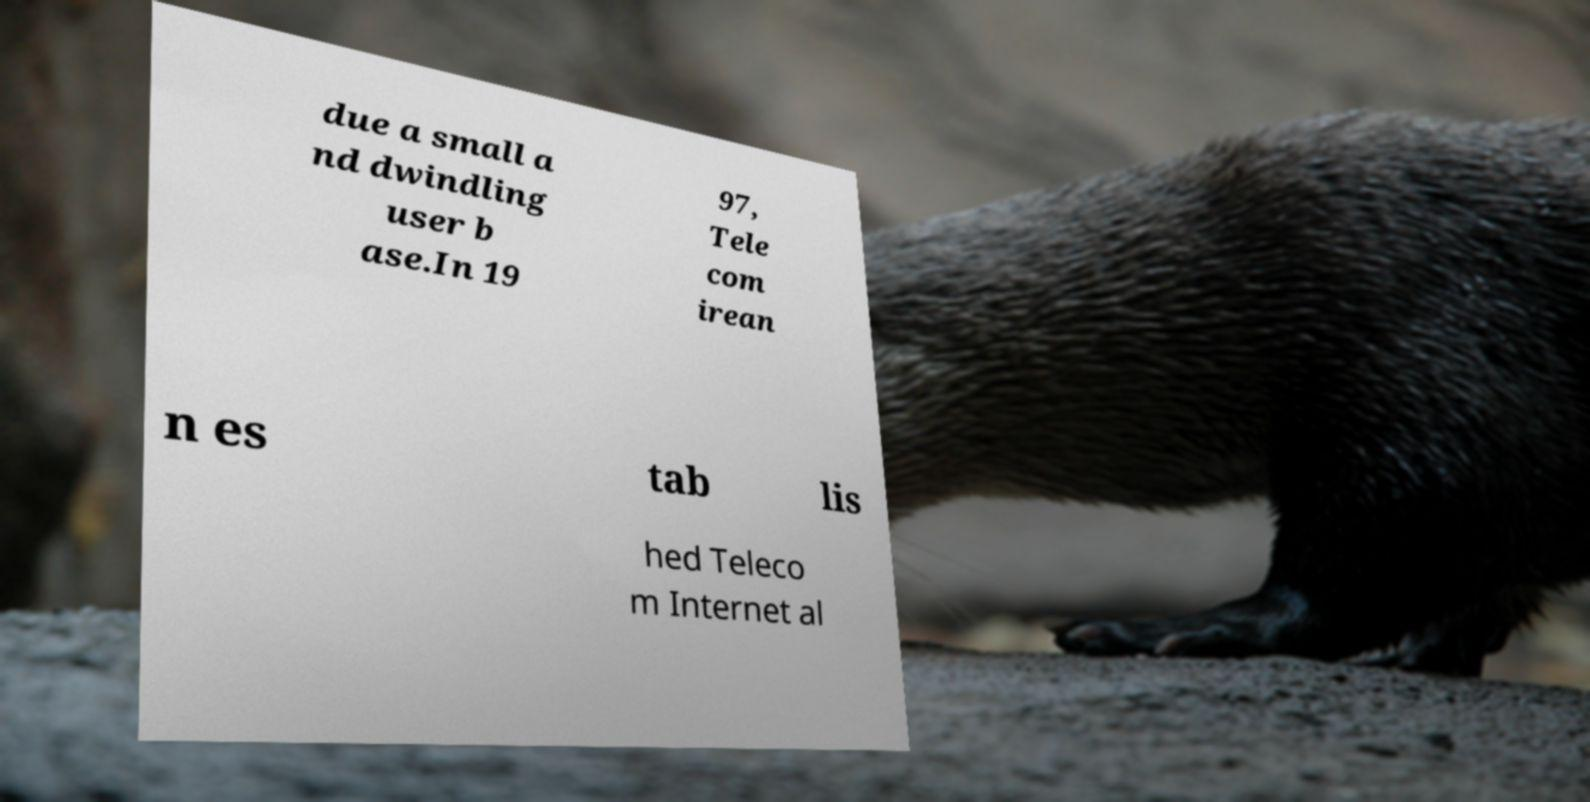For documentation purposes, I need the text within this image transcribed. Could you provide that? due a small a nd dwindling user b ase.In 19 97, Tele com irean n es tab lis hed Teleco m Internet al 